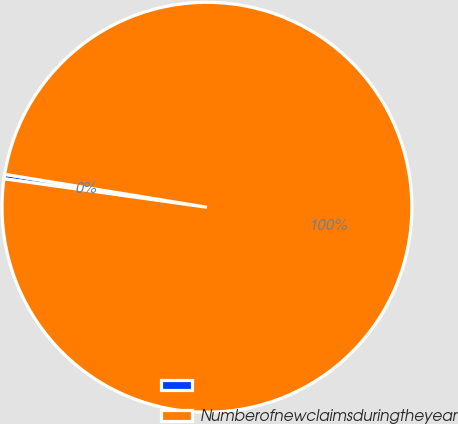<chart> <loc_0><loc_0><loc_500><loc_500><pie_chart><ecel><fcel>Numberofnewclaimsduringtheyear<nl><fcel>0.35%<fcel>99.65%<nl></chart> 